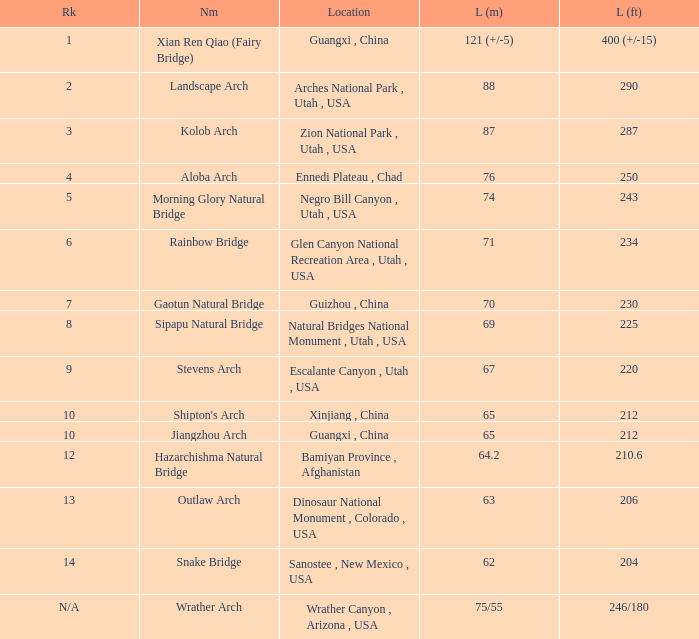What is the length in feet of the Jiangzhou arch? 212.0. 